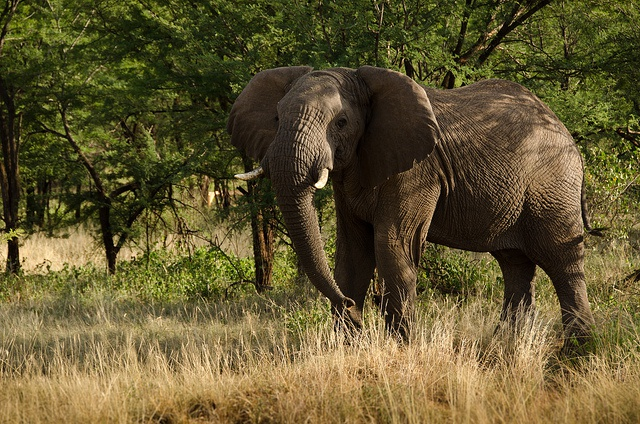Describe the objects in this image and their specific colors. I can see a elephant in darkgreen, black, gray, and tan tones in this image. 